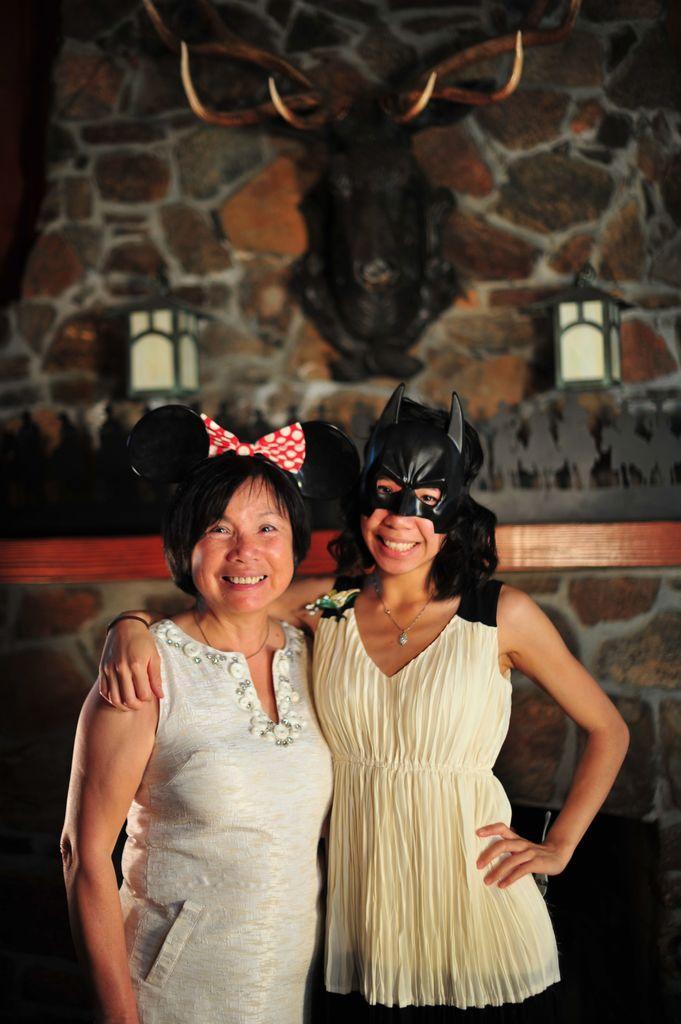Can you describe this image briefly? In this image, we can see a woman wearing a mask and holding another woman standing beside her. She is wearing a bow on her head. In the background, we can see the wall, showpieces and some objects. 